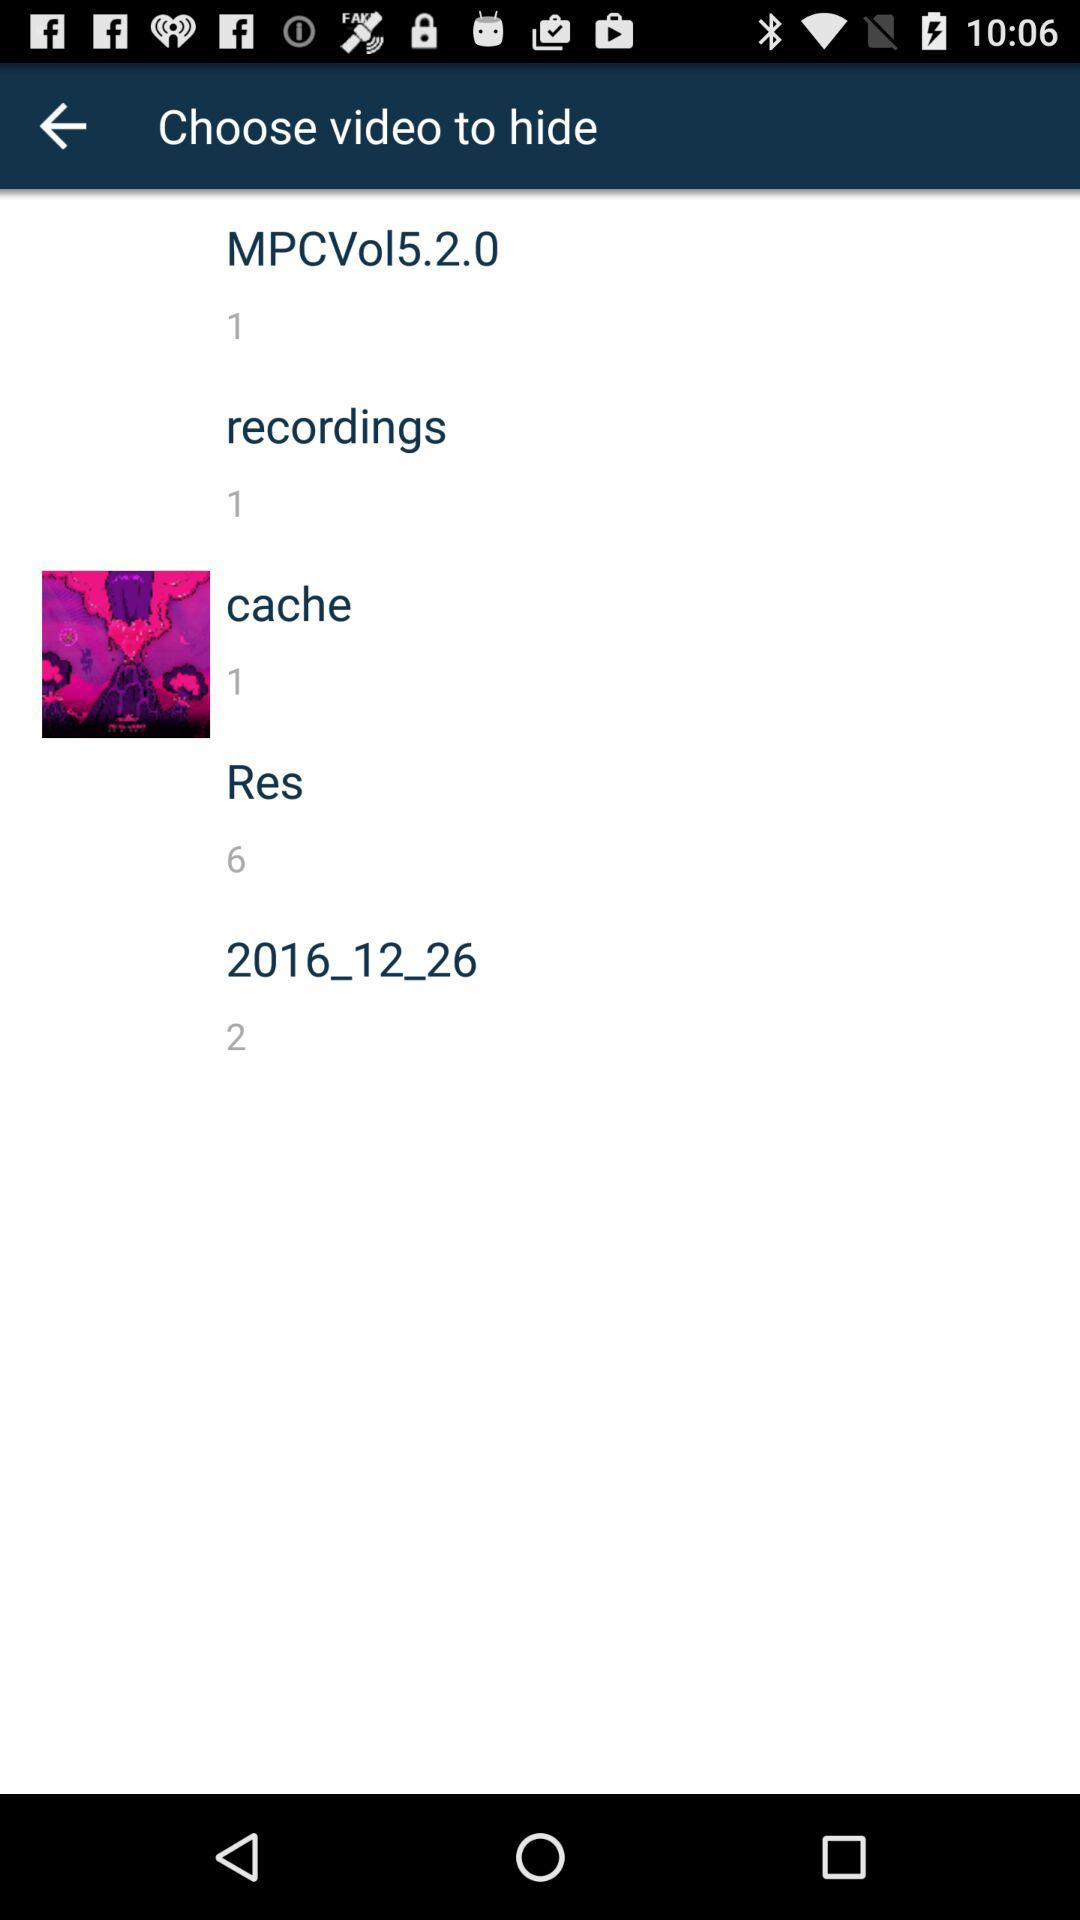How many videos are there in the "cache" folder? There is 1 video in the "cache" folder. 